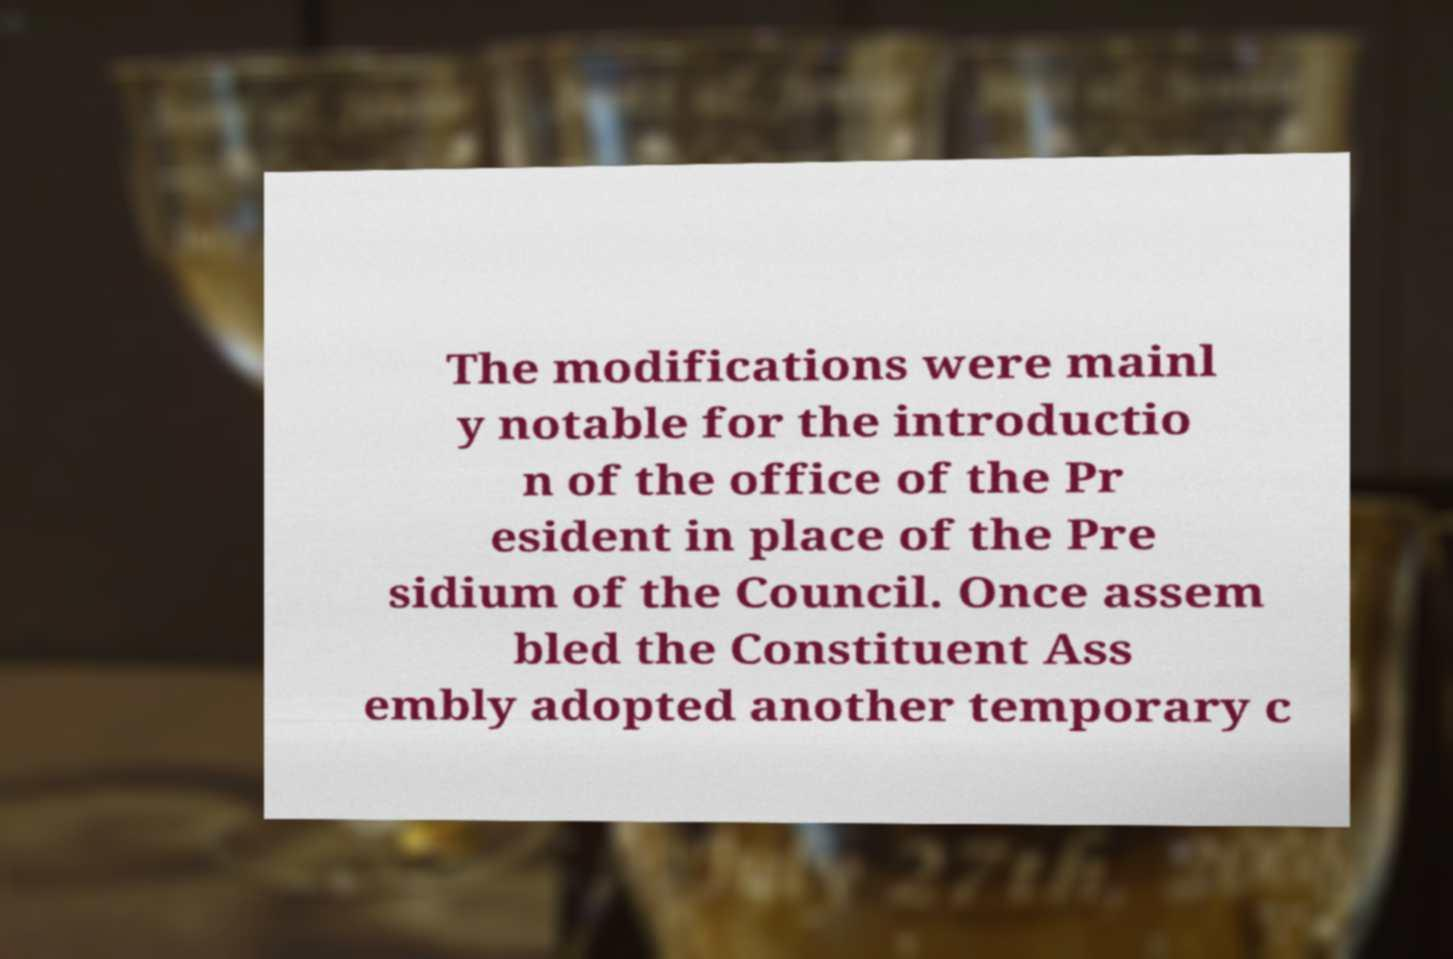There's text embedded in this image that I need extracted. Can you transcribe it verbatim? The modifications were mainl y notable for the introductio n of the office of the Pr esident in place of the Pre sidium of the Council. Once assem bled the Constituent Ass embly adopted another temporary c 